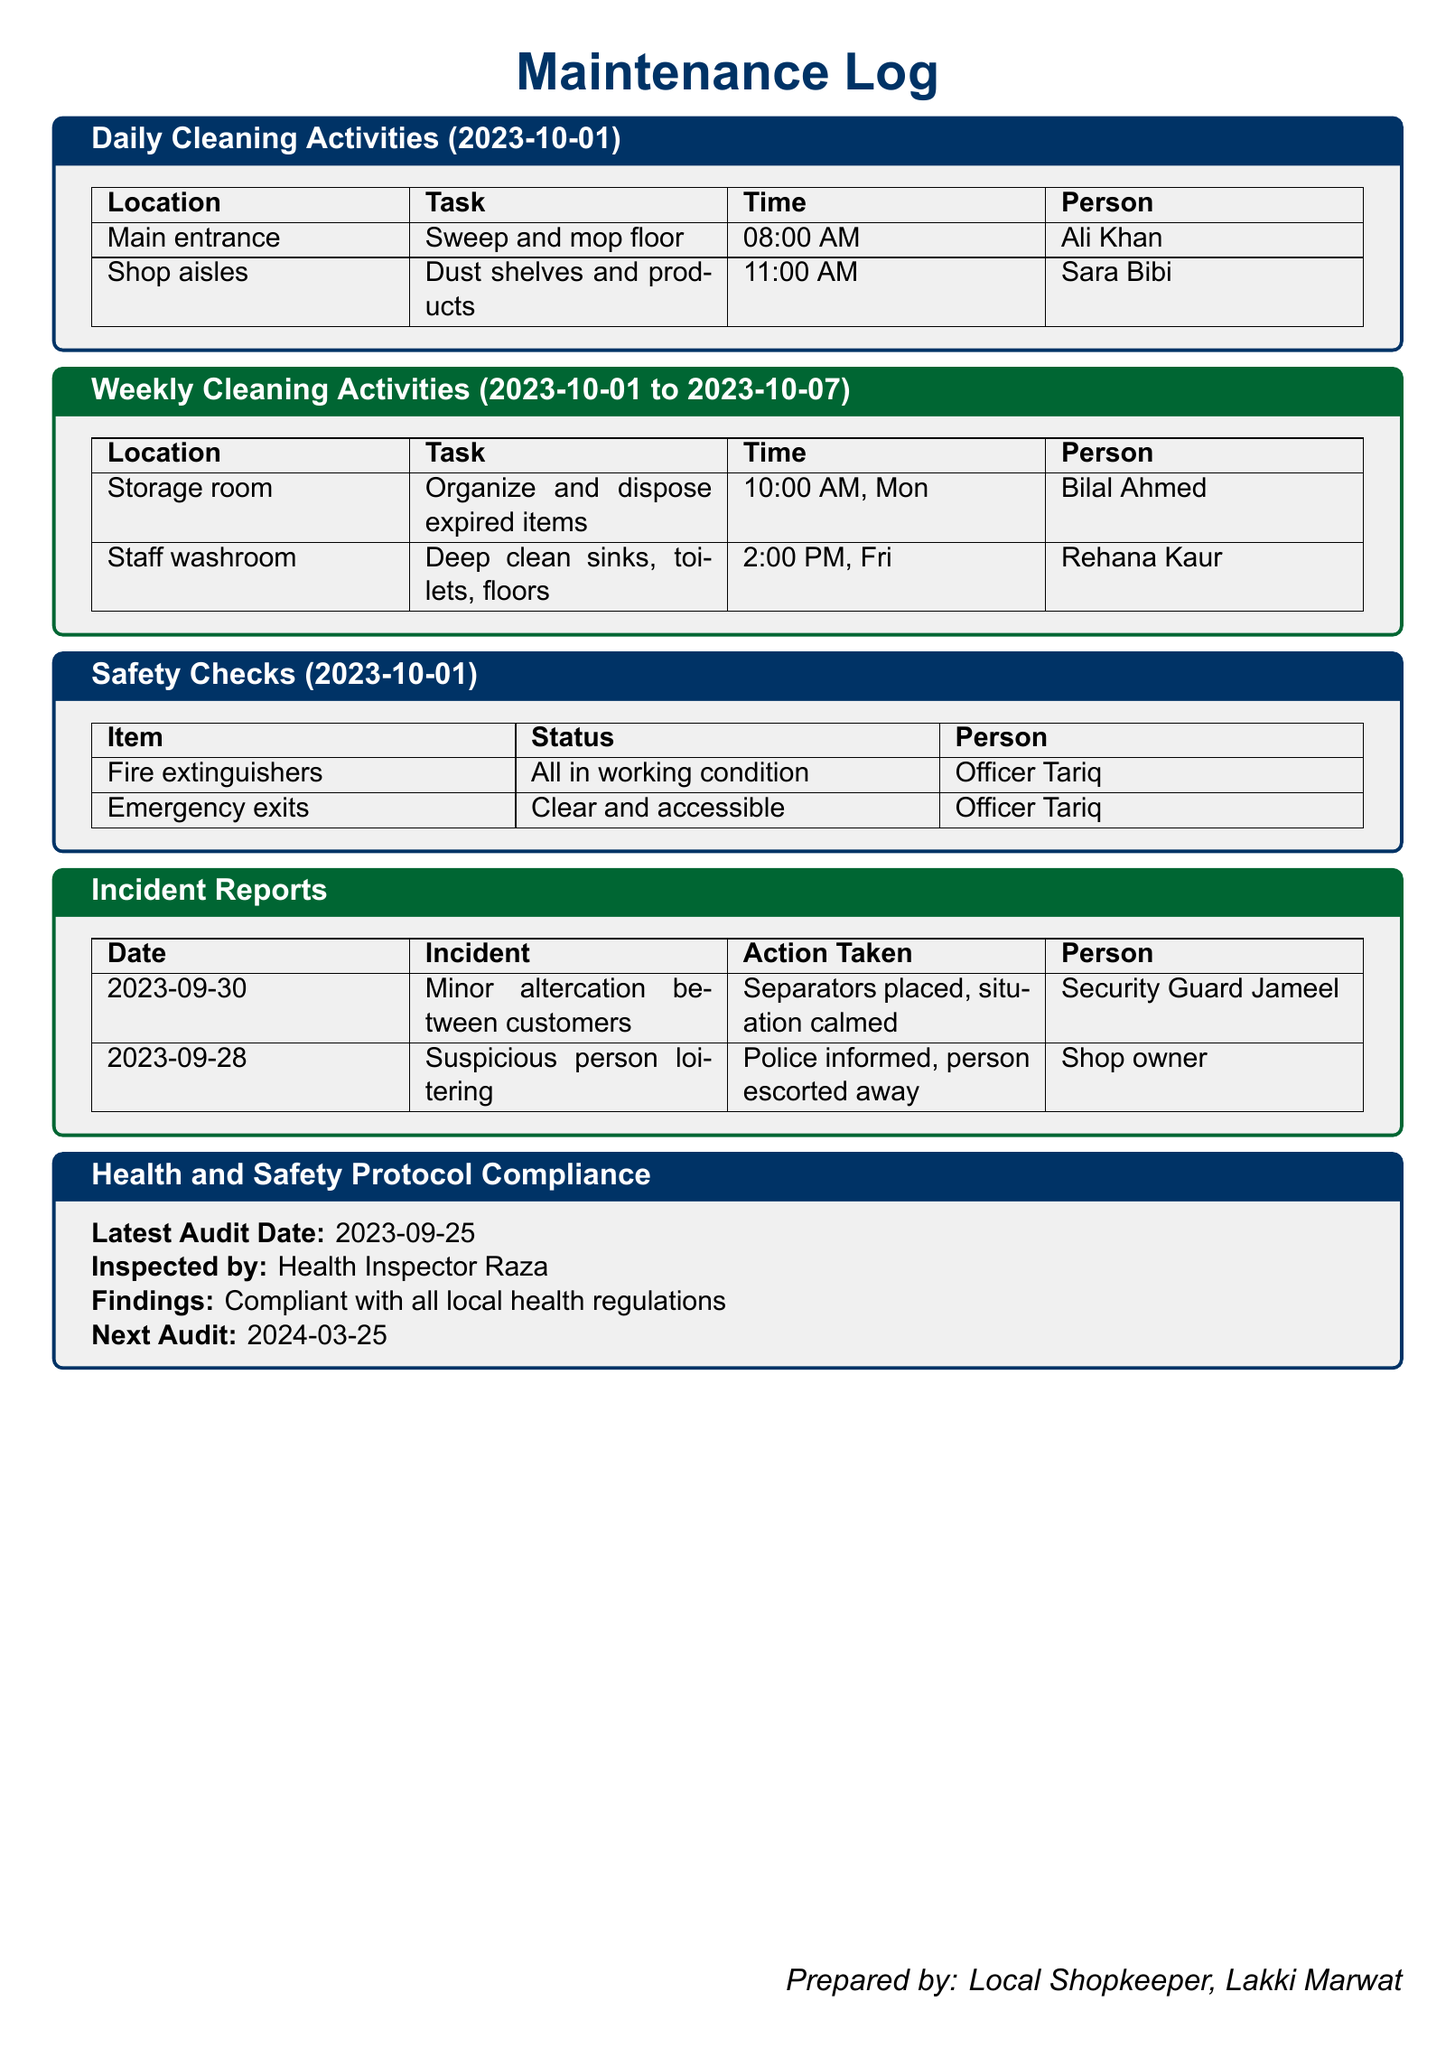what date did the latest health audit occur? The latest audit date is listed under the Health and Safety Protocol Compliance section.
Answer: 2023-09-25 who performed the safety checks? The person responsible for the safety checks is mentioned in the Safety Checks section.
Answer: Officer Tariq what was the task performed in the storage room? The task in the storage room is described in the Weekly Cleaning Activities section.
Answer: Organize and dispose expired items what was the action taken during the minor altercation? The action taken is noted in the Incident Reports section, specifically for the incident on 2023-09-30.
Answer: Separators placed, situation calmed how many fire extinguishers were checked during safety checks? The number of fire extinguishers checked can be inferred from the Safety Checks section's details.
Answer: All who is responsible for deep cleaning the staff washroom? The person responsible for this task is mentioned in the Weekly Cleaning Activities section.
Answer: Rehana Kaur when is the next health audit scheduled? The date for the next audit is found in the Health and Safety Protocol Compliance section.
Answer: 2024-03-25 what time was the floor mopped at the main entrance? The time of this task is noted in the Daily Cleaning Activities section.
Answer: 08:00 AM what incident occurred on 2023-09-28? The specific incident is described in the Incident Reports section.
Answer: Suspicious person loitering what was the finding of the latest health audit? The finding is presented in the Health and Safety Protocol Compliance section.
Answer: Compliant with all local health regulations 